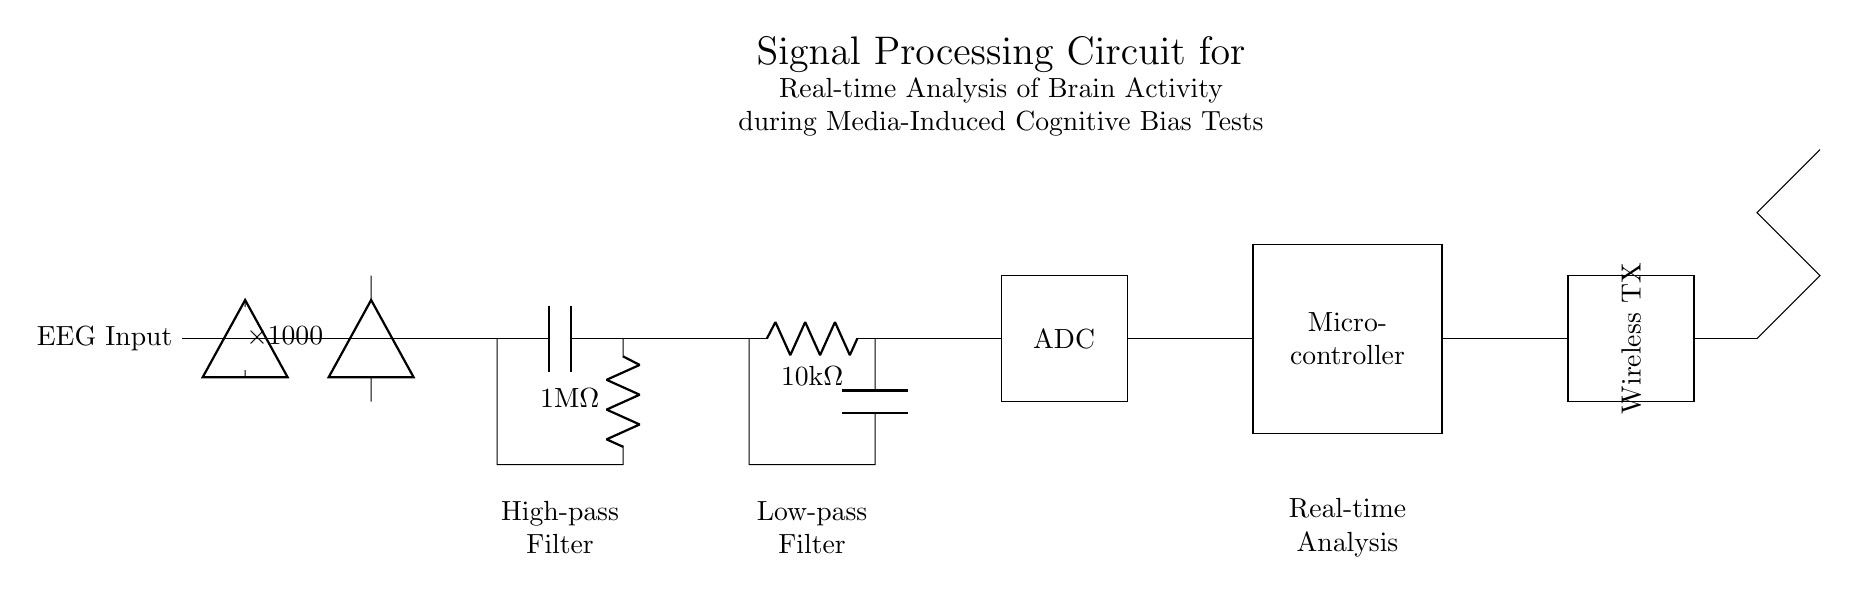What is the component type used for amplifying the signal? An operational amplifier, indicated by the "amp" symbol in the diagram, is used to amplify the EEG input signal by a factor of 1000 as shown in the circuit.
Answer: operational amplifier What is the resistance value of the low-pass filter? The low-pass filter is composed of a resistor labeled as 10k ohms, which is clearly indicated near the corresponding circuit symbol in the diagram.
Answer: 10k ohms What is the function of the high-pass filter in this circuit? The high-pass filter allows high-frequency signals to pass while blocking low-frequency signals, which is necessary for isolating brain activity from slower noise or artifacts in the EEG data.
Answer: isolation of high-frequency signals How does the signal flow through the circuit? The signal flows from the EEG input to the amplifier, then to the high-pass filter, followed by the low-pass filter, then it goes to the ADC, microcontroller, and finally to the wireless transmitter. This sequential order is represented by the arrows and connections in the diagram.
Answer: sequentially from EEG input to wireless transmitter What is the purpose of adding an ADC in the circuit? The ADC (Analog to Digital Converter) converts the amplified and filtered analog signal from the EEG into a digital format, allowing the microcontroller to process it for analysis and further actions.
Answer: conversion to digital format What is the role of the microcontroller in this setup? The microcontroller processes the digitized signals from the ADC, executing algorithms for real-time analysis of brain activity data during cognitive bias tests, and can manage communication with the wireless transmitter.
Answer: processing of brain activity data 